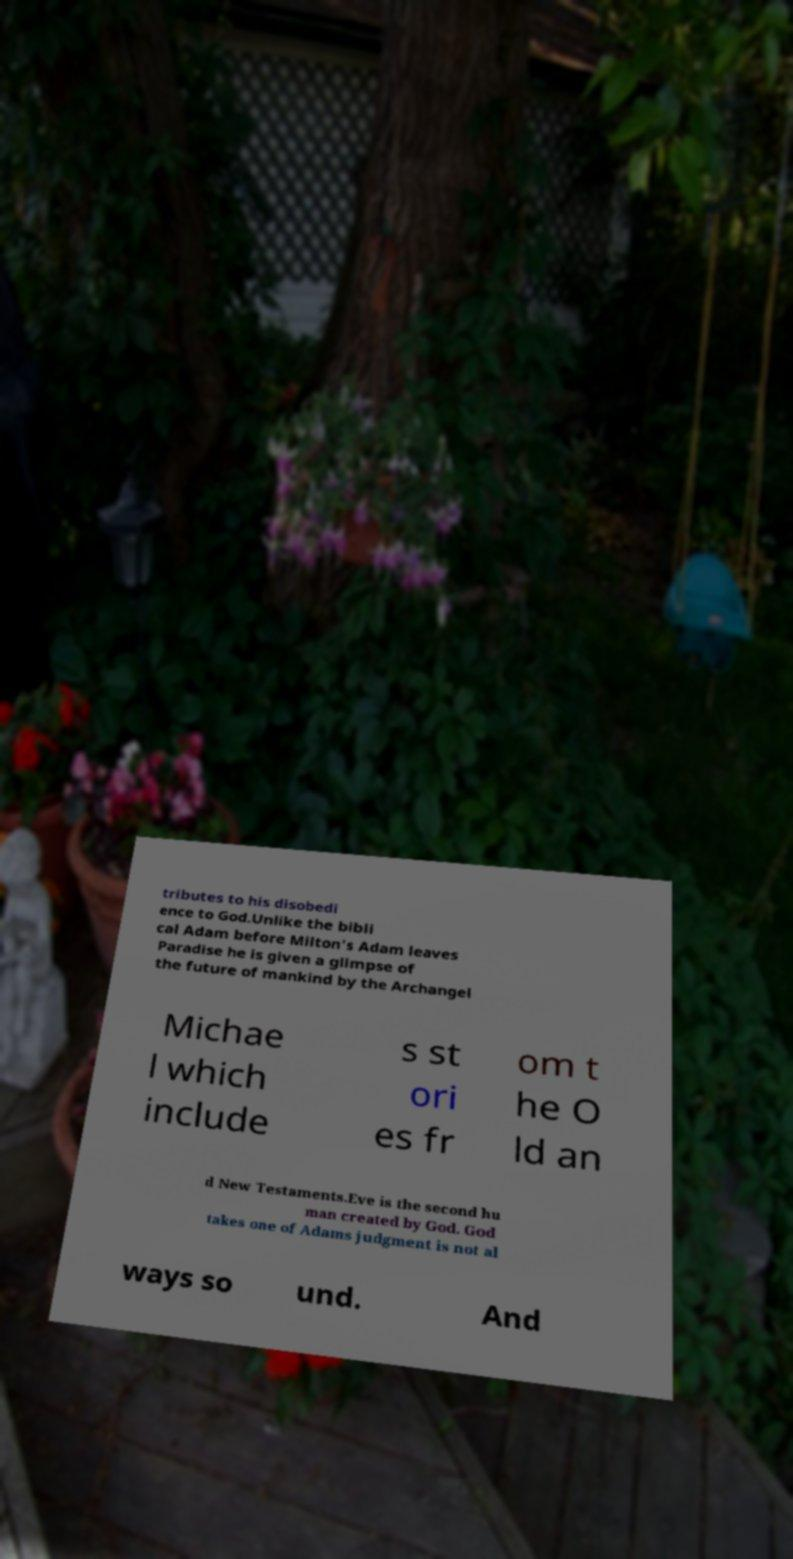What messages or text are displayed in this image? I need them in a readable, typed format. tributes to his disobedi ence to God.Unlike the bibli cal Adam before Milton's Adam leaves Paradise he is given a glimpse of the future of mankind by the Archangel Michae l which include s st ori es fr om t he O ld an d New Testaments.Eve is the second hu man created by God. God takes one of Adams judgment is not al ways so und. And 